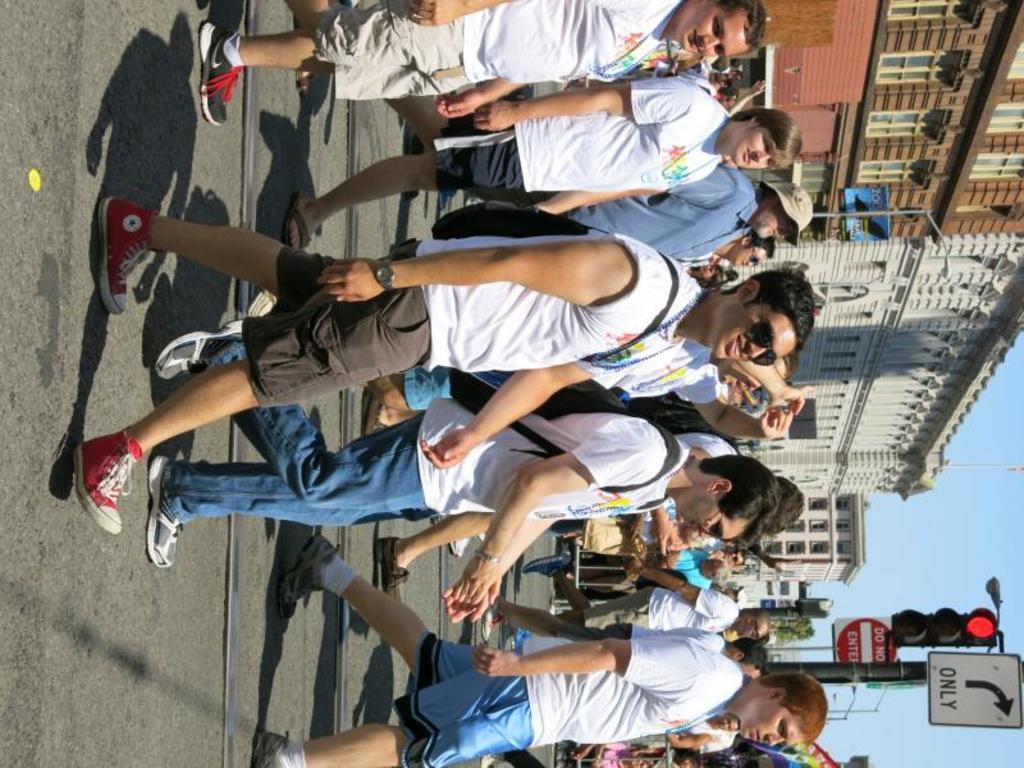Please provide a concise description of this image. In this image I can see there are groups of people walking on the road, there is a railway track on the road, in the background there are a few poles with boards and a traffic light. There are buildings at left side. 